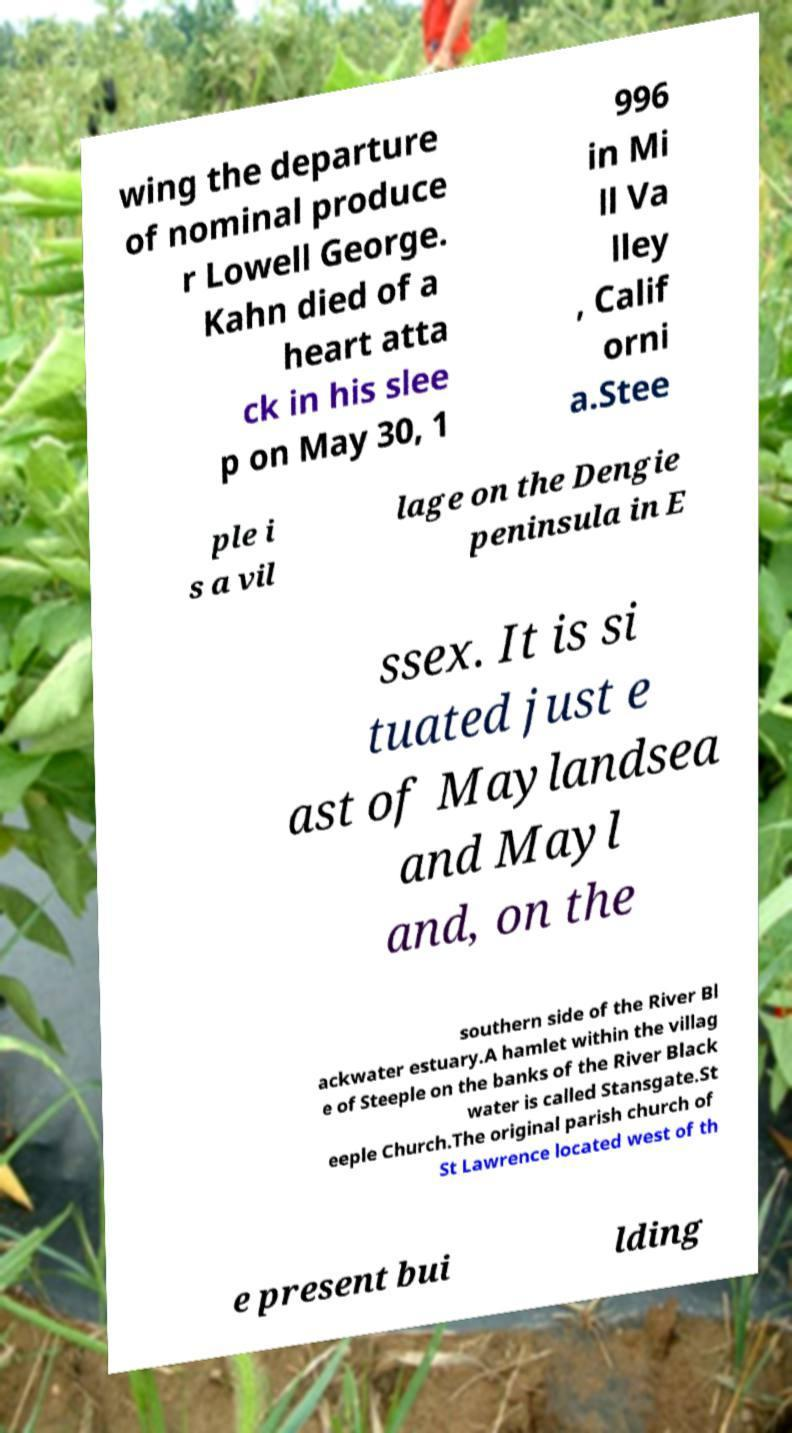I need the written content from this picture converted into text. Can you do that? wing the departure of nominal produce r Lowell George. Kahn died of a heart atta ck in his slee p on May 30, 1 996 in Mi ll Va lley , Calif orni a.Stee ple i s a vil lage on the Dengie peninsula in E ssex. It is si tuated just e ast of Maylandsea and Mayl and, on the southern side of the River Bl ackwater estuary.A hamlet within the villag e of Steeple on the banks of the River Black water is called Stansgate.St eeple Church.The original parish church of St Lawrence located west of th e present bui lding 